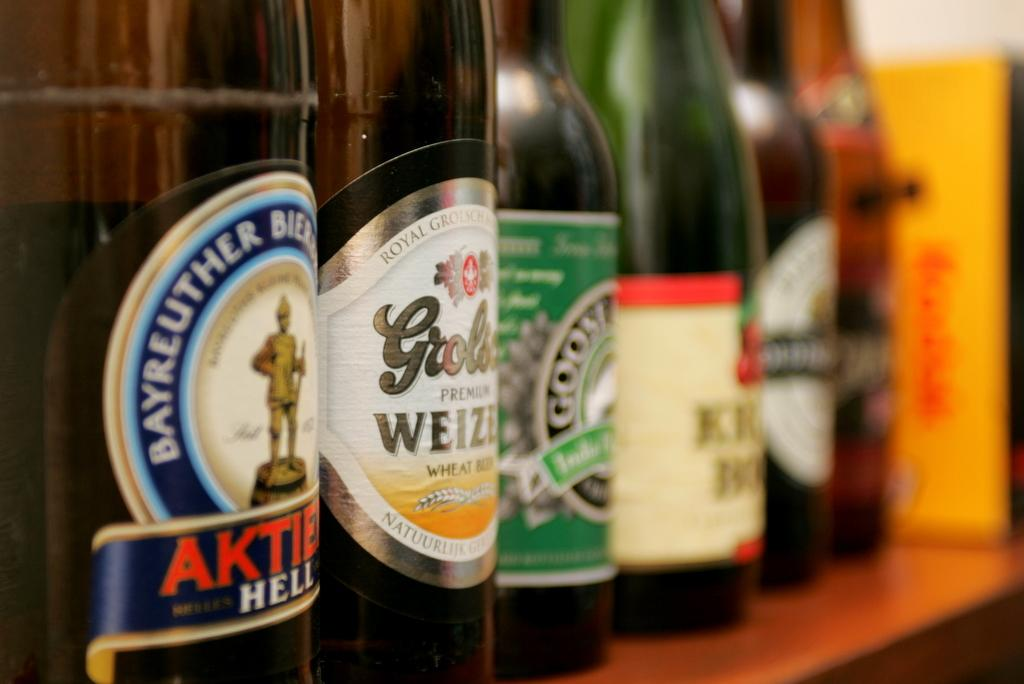<image>
Share a concise interpretation of the image provided. A bottle with the partial word Aktie on its front sticker is on a table next to many other bottles. 